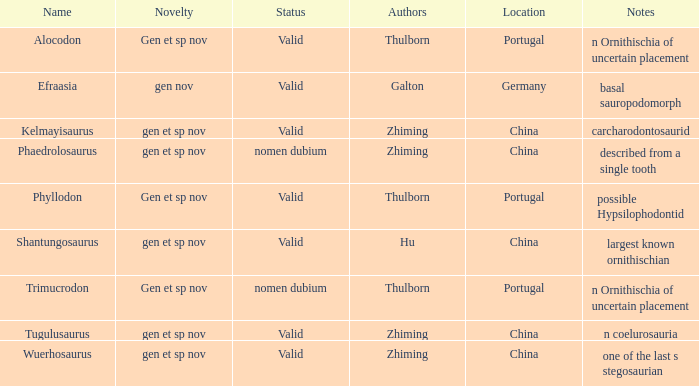What is the distinctiveness of the dinosaur identified by the author, zhiming, and with the description, "carcharodontosaurid"? Gen et sp nov. 